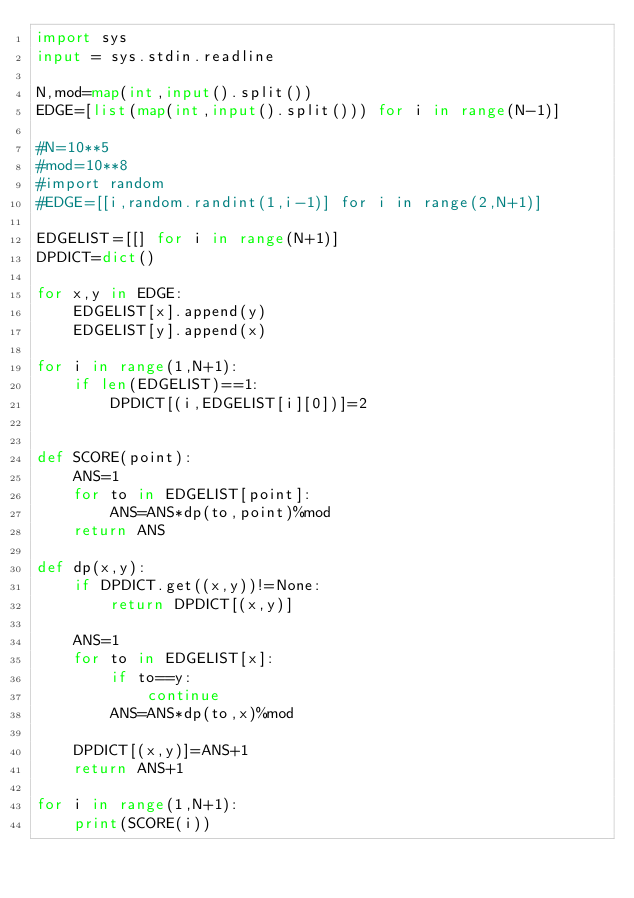<code> <loc_0><loc_0><loc_500><loc_500><_Python_>import sys
input = sys.stdin.readline

N,mod=map(int,input().split())
EDGE=[list(map(int,input().split())) for i in range(N-1)]

#N=10**5
#mod=10**8
#import random
#EDGE=[[i,random.randint(1,i-1)] for i in range(2,N+1)]

EDGELIST=[[] for i in range(N+1)]
DPDICT=dict()

for x,y in EDGE:
    EDGELIST[x].append(y)
    EDGELIST[y].append(x)

for i in range(1,N+1):
    if len(EDGELIST)==1:
        DPDICT[(i,EDGELIST[i][0])]=2    


def SCORE(point):
    ANS=1
    for to in EDGELIST[point]:
        ANS=ANS*dp(to,point)%mod
    return ANS

def dp(x,y):
    if DPDICT.get((x,y))!=None:
        return DPDICT[(x,y)]

    ANS=1
    for to in EDGELIST[x]:
        if to==y:
            continue
        ANS=ANS*dp(to,x)%mod

    DPDICT[(x,y)]=ANS+1
    return ANS+1

for i in range(1,N+1):
    print(SCORE(i))</code> 